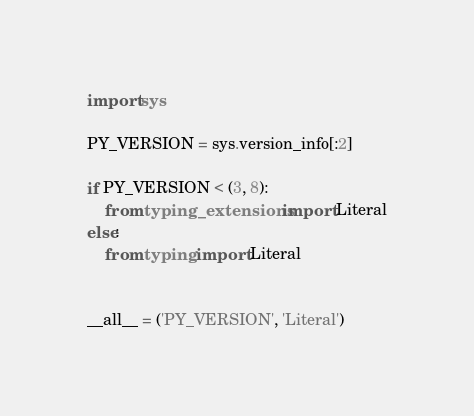Convert code to text. <code><loc_0><loc_0><loc_500><loc_500><_Python_>import sys

PY_VERSION = sys.version_info[:2]

if PY_VERSION < (3, 8):
    from typing_extensions import Literal
else:
    from typing import Literal


__all__ = ('PY_VERSION', 'Literal')
</code> 